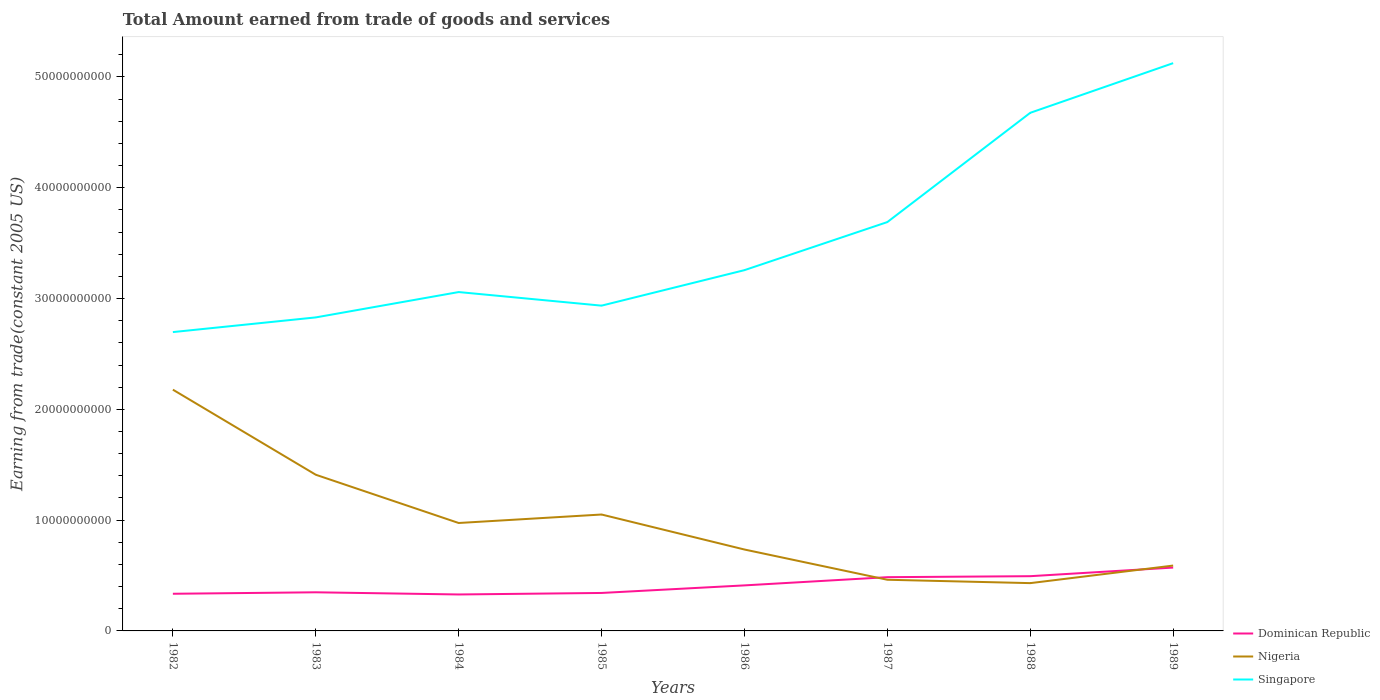Does the line corresponding to Nigeria intersect with the line corresponding to Singapore?
Your response must be concise. No. Is the number of lines equal to the number of legend labels?
Offer a terse response. Yes. Across all years, what is the maximum total amount earned by trading goods and services in Singapore?
Offer a terse response. 2.70e+1. What is the total total amount earned by trading goods and services in Dominican Republic in the graph?
Offer a terse response. -1.56e+09. What is the difference between the highest and the second highest total amount earned by trading goods and services in Nigeria?
Provide a short and direct response. 1.75e+1. What is the difference between the highest and the lowest total amount earned by trading goods and services in Dominican Republic?
Make the answer very short. 3. How many lines are there?
Keep it short and to the point. 3. How many years are there in the graph?
Offer a terse response. 8. What is the difference between two consecutive major ticks on the Y-axis?
Your answer should be compact. 1.00e+1. Are the values on the major ticks of Y-axis written in scientific E-notation?
Give a very brief answer. No. How are the legend labels stacked?
Make the answer very short. Vertical. What is the title of the graph?
Ensure brevity in your answer.  Total Amount earned from trade of goods and services. Does "Czech Republic" appear as one of the legend labels in the graph?
Ensure brevity in your answer.  No. What is the label or title of the X-axis?
Your response must be concise. Years. What is the label or title of the Y-axis?
Your answer should be compact. Earning from trade(constant 2005 US). What is the Earning from trade(constant 2005 US) of Dominican Republic in 1982?
Your answer should be compact. 3.35e+09. What is the Earning from trade(constant 2005 US) of Nigeria in 1982?
Your answer should be very brief. 2.18e+1. What is the Earning from trade(constant 2005 US) in Singapore in 1982?
Your response must be concise. 2.70e+1. What is the Earning from trade(constant 2005 US) in Dominican Republic in 1983?
Your answer should be compact. 3.49e+09. What is the Earning from trade(constant 2005 US) of Nigeria in 1983?
Keep it short and to the point. 1.41e+1. What is the Earning from trade(constant 2005 US) of Singapore in 1983?
Offer a terse response. 2.83e+1. What is the Earning from trade(constant 2005 US) in Dominican Republic in 1984?
Your response must be concise. 3.29e+09. What is the Earning from trade(constant 2005 US) in Nigeria in 1984?
Keep it short and to the point. 9.74e+09. What is the Earning from trade(constant 2005 US) of Singapore in 1984?
Make the answer very short. 3.06e+1. What is the Earning from trade(constant 2005 US) in Dominican Republic in 1985?
Your response must be concise. 3.43e+09. What is the Earning from trade(constant 2005 US) of Nigeria in 1985?
Give a very brief answer. 1.05e+1. What is the Earning from trade(constant 2005 US) in Singapore in 1985?
Offer a very short reply. 2.94e+1. What is the Earning from trade(constant 2005 US) of Dominican Republic in 1986?
Your answer should be very brief. 4.11e+09. What is the Earning from trade(constant 2005 US) in Nigeria in 1986?
Offer a very short reply. 7.35e+09. What is the Earning from trade(constant 2005 US) in Singapore in 1986?
Offer a terse response. 3.26e+1. What is the Earning from trade(constant 2005 US) of Dominican Republic in 1987?
Your answer should be very brief. 4.85e+09. What is the Earning from trade(constant 2005 US) of Nigeria in 1987?
Ensure brevity in your answer.  4.62e+09. What is the Earning from trade(constant 2005 US) in Singapore in 1987?
Ensure brevity in your answer.  3.69e+1. What is the Earning from trade(constant 2005 US) of Dominican Republic in 1988?
Your answer should be compact. 4.94e+09. What is the Earning from trade(constant 2005 US) of Nigeria in 1988?
Ensure brevity in your answer.  4.31e+09. What is the Earning from trade(constant 2005 US) in Singapore in 1988?
Offer a terse response. 4.68e+1. What is the Earning from trade(constant 2005 US) of Dominican Republic in 1989?
Ensure brevity in your answer.  5.72e+09. What is the Earning from trade(constant 2005 US) in Nigeria in 1989?
Offer a very short reply. 5.90e+09. What is the Earning from trade(constant 2005 US) of Singapore in 1989?
Keep it short and to the point. 5.12e+1. Across all years, what is the maximum Earning from trade(constant 2005 US) of Dominican Republic?
Your answer should be very brief. 5.72e+09. Across all years, what is the maximum Earning from trade(constant 2005 US) in Nigeria?
Offer a very short reply. 2.18e+1. Across all years, what is the maximum Earning from trade(constant 2005 US) of Singapore?
Your response must be concise. 5.12e+1. Across all years, what is the minimum Earning from trade(constant 2005 US) in Dominican Republic?
Offer a very short reply. 3.29e+09. Across all years, what is the minimum Earning from trade(constant 2005 US) in Nigeria?
Provide a short and direct response. 4.31e+09. Across all years, what is the minimum Earning from trade(constant 2005 US) of Singapore?
Provide a short and direct response. 2.70e+1. What is the total Earning from trade(constant 2005 US) of Dominican Republic in the graph?
Keep it short and to the point. 3.32e+1. What is the total Earning from trade(constant 2005 US) of Nigeria in the graph?
Keep it short and to the point. 7.83e+1. What is the total Earning from trade(constant 2005 US) in Singapore in the graph?
Offer a very short reply. 2.83e+11. What is the difference between the Earning from trade(constant 2005 US) in Dominican Republic in 1982 and that in 1983?
Offer a very short reply. -1.32e+08. What is the difference between the Earning from trade(constant 2005 US) in Nigeria in 1982 and that in 1983?
Provide a succinct answer. 7.68e+09. What is the difference between the Earning from trade(constant 2005 US) of Singapore in 1982 and that in 1983?
Ensure brevity in your answer.  -1.33e+09. What is the difference between the Earning from trade(constant 2005 US) in Dominican Republic in 1982 and that in 1984?
Give a very brief answer. 6.42e+07. What is the difference between the Earning from trade(constant 2005 US) in Nigeria in 1982 and that in 1984?
Provide a succinct answer. 1.20e+1. What is the difference between the Earning from trade(constant 2005 US) in Singapore in 1982 and that in 1984?
Offer a very short reply. -3.61e+09. What is the difference between the Earning from trade(constant 2005 US) in Dominican Republic in 1982 and that in 1985?
Provide a succinct answer. -7.25e+07. What is the difference between the Earning from trade(constant 2005 US) in Nigeria in 1982 and that in 1985?
Offer a terse response. 1.13e+1. What is the difference between the Earning from trade(constant 2005 US) in Singapore in 1982 and that in 1985?
Offer a terse response. -2.39e+09. What is the difference between the Earning from trade(constant 2005 US) of Dominican Republic in 1982 and that in 1986?
Offer a very short reply. -7.56e+08. What is the difference between the Earning from trade(constant 2005 US) in Nigeria in 1982 and that in 1986?
Provide a succinct answer. 1.44e+1. What is the difference between the Earning from trade(constant 2005 US) of Singapore in 1982 and that in 1986?
Your answer should be compact. -5.59e+09. What is the difference between the Earning from trade(constant 2005 US) in Dominican Republic in 1982 and that in 1987?
Provide a short and direct response. -1.50e+09. What is the difference between the Earning from trade(constant 2005 US) in Nigeria in 1982 and that in 1987?
Make the answer very short. 1.72e+1. What is the difference between the Earning from trade(constant 2005 US) in Singapore in 1982 and that in 1987?
Your answer should be compact. -9.93e+09. What is the difference between the Earning from trade(constant 2005 US) in Dominican Republic in 1982 and that in 1988?
Provide a short and direct response. -1.59e+09. What is the difference between the Earning from trade(constant 2005 US) in Nigeria in 1982 and that in 1988?
Give a very brief answer. 1.75e+1. What is the difference between the Earning from trade(constant 2005 US) of Singapore in 1982 and that in 1988?
Offer a very short reply. -1.98e+1. What is the difference between the Earning from trade(constant 2005 US) in Dominican Republic in 1982 and that in 1989?
Give a very brief answer. -2.36e+09. What is the difference between the Earning from trade(constant 2005 US) of Nigeria in 1982 and that in 1989?
Your answer should be compact. 1.59e+1. What is the difference between the Earning from trade(constant 2005 US) in Singapore in 1982 and that in 1989?
Offer a very short reply. -2.43e+1. What is the difference between the Earning from trade(constant 2005 US) in Dominican Republic in 1983 and that in 1984?
Make the answer very short. 1.96e+08. What is the difference between the Earning from trade(constant 2005 US) of Nigeria in 1983 and that in 1984?
Give a very brief answer. 4.36e+09. What is the difference between the Earning from trade(constant 2005 US) in Singapore in 1983 and that in 1984?
Your response must be concise. -2.29e+09. What is the difference between the Earning from trade(constant 2005 US) of Dominican Republic in 1983 and that in 1985?
Give a very brief answer. 5.93e+07. What is the difference between the Earning from trade(constant 2005 US) of Nigeria in 1983 and that in 1985?
Your response must be concise. 3.59e+09. What is the difference between the Earning from trade(constant 2005 US) of Singapore in 1983 and that in 1985?
Give a very brief answer. -1.06e+09. What is the difference between the Earning from trade(constant 2005 US) of Dominican Republic in 1983 and that in 1986?
Offer a terse response. -6.24e+08. What is the difference between the Earning from trade(constant 2005 US) in Nigeria in 1983 and that in 1986?
Provide a short and direct response. 6.75e+09. What is the difference between the Earning from trade(constant 2005 US) in Singapore in 1983 and that in 1986?
Ensure brevity in your answer.  -4.27e+09. What is the difference between the Earning from trade(constant 2005 US) of Dominican Republic in 1983 and that in 1987?
Your answer should be compact. -1.36e+09. What is the difference between the Earning from trade(constant 2005 US) of Nigeria in 1983 and that in 1987?
Ensure brevity in your answer.  9.48e+09. What is the difference between the Earning from trade(constant 2005 US) of Singapore in 1983 and that in 1987?
Offer a very short reply. -8.60e+09. What is the difference between the Earning from trade(constant 2005 US) of Dominican Republic in 1983 and that in 1988?
Your response must be concise. -1.45e+09. What is the difference between the Earning from trade(constant 2005 US) of Nigeria in 1983 and that in 1988?
Your response must be concise. 9.78e+09. What is the difference between the Earning from trade(constant 2005 US) of Singapore in 1983 and that in 1988?
Ensure brevity in your answer.  -1.85e+1. What is the difference between the Earning from trade(constant 2005 US) of Dominican Republic in 1983 and that in 1989?
Your answer should be very brief. -2.23e+09. What is the difference between the Earning from trade(constant 2005 US) in Nigeria in 1983 and that in 1989?
Your response must be concise. 8.20e+09. What is the difference between the Earning from trade(constant 2005 US) in Singapore in 1983 and that in 1989?
Make the answer very short. -2.29e+1. What is the difference between the Earning from trade(constant 2005 US) of Dominican Republic in 1984 and that in 1985?
Your answer should be compact. -1.37e+08. What is the difference between the Earning from trade(constant 2005 US) in Nigeria in 1984 and that in 1985?
Your answer should be compact. -7.65e+08. What is the difference between the Earning from trade(constant 2005 US) in Singapore in 1984 and that in 1985?
Make the answer very short. 1.23e+09. What is the difference between the Earning from trade(constant 2005 US) of Dominican Republic in 1984 and that in 1986?
Keep it short and to the point. -8.20e+08. What is the difference between the Earning from trade(constant 2005 US) in Nigeria in 1984 and that in 1986?
Provide a succinct answer. 2.39e+09. What is the difference between the Earning from trade(constant 2005 US) in Singapore in 1984 and that in 1986?
Give a very brief answer. -1.98e+09. What is the difference between the Earning from trade(constant 2005 US) of Dominican Republic in 1984 and that in 1987?
Ensure brevity in your answer.  -1.56e+09. What is the difference between the Earning from trade(constant 2005 US) in Nigeria in 1984 and that in 1987?
Make the answer very short. 5.12e+09. What is the difference between the Earning from trade(constant 2005 US) of Singapore in 1984 and that in 1987?
Ensure brevity in your answer.  -6.32e+09. What is the difference between the Earning from trade(constant 2005 US) in Dominican Republic in 1984 and that in 1988?
Your answer should be very brief. -1.65e+09. What is the difference between the Earning from trade(constant 2005 US) of Nigeria in 1984 and that in 1988?
Your answer should be compact. 5.43e+09. What is the difference between the Earning from trade(constant 2005 US) of Singapore in 1984 and that in 1988?
Your response must be concise. -1.62e+1. What is the difference between the Earning from trade(constant 2005 US) in Dominican Republic in 1984 and that in 1989?
Offer a terse response. -2.43e+09. What is the difference between the Earning from trade(constant 2005 US) of Nigeria in 1984 and that in 1989?
Your answer should be compact. 3.84e+09. What is the difference between the Earning from trade(constant 2005 US) of Singapore in 1984 and that in 1989?
Your response must be concise. -2.07e+1. What is the difference between the Earning from trade(constant 2005 US) of Dominican Republic in 1985 and that in 1986?
Your answer should be compact. -6.84e+08. What is the difference between the Earning from trade(constant 2005 US) in Nigeria in 1985 and that in 1986?
Your response must be concise. 3.16e+09. What is the difference between the Earning from trade(constant 2005 US) of Singapore in 1985 and that in 1986?
Your response must be concise. -3.20e+09. What is the difference between the Earning from trade(constant 2005 US) of Dominican Republic in 1985 and that in 1987?
Your answer should be very brief. -1.42e+09. What is the difference between the Earning from trade(constant 2005 US) in Nigeria in 1985 and that in 1987?
Your response must be concise. 5.89e+09. What is the difference between the Earning from trade(constant 2005 US) of Singapore in 1985 and that in 1987?
Your response must be concise. -7.54e+09. What is the difference between the Earning from trade(constant 2005 US) in Dominican Republic in 1985 and that in 1988?
Offer a very short reply. -1.51e+09. What is the difference between the Earning from trade(constant 2005 US) in Nigeria in 1985 and that in 1988?
Your response must be concise. 6.19e+09. What is the difference between the Earning from trade(constant 2005 US) of Singapore in 1985 and that in 1988?
Offer a terse response. -1.74e+1. What is the difference between the Earning from trade(constant 2005 US) in Dominican Republic in 1985 and that in 1989?
Your answer should be compact. -2.29e+09. What is the difference between the Earning from trade(constant 2005 US) in Nigeria in 1985 and that in 1989?
Make the answer very short. 4.61e+09. What is the difference between the Earning from trade(constant 2005 US) in Singapore in 1985 and that in 1989?
Make the answer very short. -2.19e+1. What is the difference between the Earning from trade(constant 2005 US) of Dominican Republic in 1986 and that in 1987?
Give a very brief answer. -7.41e+08. What is the difference between the Earning from trade(constant 2005 US) in Nigeria in 1986 and that in 1987?
Your answer should be compact. 2.73e+09. What is the difference between the Earning from trade(constant 2005 US) of Singapore in 1986 and that in 1987?
Your answer should be very brief. -4.34e+09. What is the difference between the Earning from trade(constant 2005 US) in Dominican Republic in 1986 and that in 1988?
Ensure brevity in your answer.  -8.30e+08. What is the difference between the Earning from trade(constant 2005 US) of Nigeria in 1986 and that in 1988?
Ensure brevity in your answer.  3.03e+09. What is the difference between the Earning from trade(constant 2005 US) in Singapore in 1986 and that in 1988?
Keep it short and to the point. -1.42e+1. What is the difference between the Earning from trade(constant 2005 US) in Dominican Republic in 1986 and that in 1989?
Offer a terse response. -1.61e+09. What is the difference between the Earning from trade(constant 2005 US) of Nigeria in 1986 and that in 1989?
Keep it short and to the point. 1.45e+09. What is the difference between the Earning from trade(constant 2005 US) in Singapore in 1986 and that in 1989?
Offer a very short reply. -1.87e+1. What is the difference between the Earning from trade(constant 2005 US) of Dominican Republic in 1987 and that in 1988?
Your answer should be very brief. -8.89e+07. What is the difference between the Earning from trade(constant 2005 US) in Nigeria in 1987 and that in 1988?
Provide a succinct answer. 3.05e+08. What is the difference between the Earning from trade(constant 2005 US) of Singapore in 1987 and that in 1988?
Your answer should be compact. -9.86e+09. What is the difference between the Earning from trade(constant 2005 US) of Dominican Republic in 1987 and that in 1989?
Provide a short and direct response. -8.68e+08. What is the difference between the Earning from trade(constant 2005 US) of Nigeria in 1987 and that in 1989?
Offer a terse response. -1.28e+09. What is the difference between the Earning from trade(constant 2005 US) in Singapore in 1987 and that in 1989?
Make the answer very short. -1.43e+1. What is the difference between the Earning from trade(constant 2005 US) of Dominican Republic in 1988 and that in 1989?
Keep it short and to the point. -7.79e+08. What is the difference between the Earning from trade(constant 2005 US) in Nigeria in 1988 and that in 1989?
Ensure brevity in your answer.  -1.59e+09. What is the difference between the Earning from trade(constant 2005 US) of Singapore in 1988 and that in 1989?
Give a very brief answer. -4.48e+09. What is the difference between the Earning from trade(constant 2005 US) in Dominican Republic in 1982 and the Earning from trade(constant 2005 US) in Nigeria in 1983?
Ensure brevity in your answer.  -1.07e+1. What is the difference between the Earning from trade(constant 2005 US) in Dominican Republic in 1982 and the Earning from trade(constant 2005 US) in Singapore in 1983?
Your answer should be very brief. -2.49e+1. What is the difference between the Earning from trade(constant 2005 US) in Nigeria in 1982 and the Earning from trade(constant 2005 US) in Singapore in 1983?
Provide a short and direct response. -6.52e+09. What is the difference between the Earning from trade(constant 2005 US) of Dominican Republic in 1982 and the Earning from trade(constant 2005 US) of Nigeria in 1984?
Keep it short and to the point. -6.39e+09. What is the difference between the Earning from trade(constant 2005 US) of Dominican Republic in 1982 and the Earning from trade(constant 2005 US) of Singapore in 1984?
Provide a short and direct response. -2.72e+1. What is the difference between the Earning from trade(constant 2005 US) of Nigeria in 1982 and the Earning from trade(constant 2005 US) of Singapore in 1984?
Ensure brevity in your answer.  -8.81e+09. What is the difference between the Earning from trade(constant 2005 US) in Dominican Republic in 1982 and the Earning from trade(constant 2005 US) in Nigeria in 1985?
Offer a very short reply. -7.15e+09. What is the difference between the Earning from trade(constant 2005 US) in Dominican Republic in 1982 and the Earning from trade(constant 2005 US) in Singapore in 1985?
Give a very brief answer. -2.60e+1. What is the difference between the Earning from trade(constant 2005 US) in Nigeria in 1982 and the Earning from trade(constant 2005 US) in Singapore in 1985?
Your answer should be compact. -7.58e+09. What is the difference between the Earning from trade(constant 2005 US) of Dominican Republic in 1982 and the Earning from trade(constant 2005 US) of Nigeria in 1986?
Offer a very short reply. -3.99e+09. What is the difference between the Earning from trade(constant 2005 US) in Dominican Republic in 1982 and the Earning from trade(constant 2005 US) in Singapore in 1986?
Offer a very short reply. -2.92e+1. What is the difference between the Earning from trade(constant 2005 US) in Nigeria in 1982 and the Earning from trade(constant 2005 US) in Singapore in 1986?
Offer a very short reply. -1.08e+1. What is the difference between the Earning from trade(constant 2005 US) of Dominican Republic in 1982 and the Earning from trade(constant 2005 US) of Nigeria in 1987?
Offer a very short reply. -1.26e+09. What is the difference between the Earning from trade(constant 2005 US) in Dominican Republic in 1982 and the Earning from trade(constant 2005 US) in Singapore in 1987?
Your answer should be very brief. -3.35e+1. What is the difference between the Earning from trade(constant 2005 US) in Nigeria in 1982 and the Earning from trade(constant 2005 US) in Singapore in 1987?
Provide a succinct answer. -1.51e+1. What is the difference between the Earning from trade(constant 2005 US) in Dominican Republic in 1982 and the Earning from trade(constant 2005 US) in Nigeria in 1988?
Offer a very short reply. -9.59e+08. What is the difference between the Earning from trade(constant 2005 US) of Dominican Republic in 1982 and the Earning from trade(constant 2005 US) of Singapore in 1988?
Make the answer very short. -4.34e+1. What is the difference between the Earning from trade(constant 2005 US) in Nigeria in 1982 and the Earning from trade(constant 2005 US) in Singapore in 1988?
Ensure brevity in your answer.  -2.50e+1. What is the difference between the Earning from trade(constant 2005 US) of Dominican Republic in 1982 and the Earning from trade(constant 2005 US) of Nigeria in 1989?
Keep it short and to the point. -2.54e+09. What is the difference between the Earning from trade(constant 2005 US) of Dominican Republic in 1982 and the Earning from trade(constant 2005 US) of Singapore in 1989?
Your answer should be very brief. -4.79e+1. What is the difference between the Earning from trade(constant 2005 US) in Nigeria in 1982 and the Earning from trade(constant 2005 US) in Singapore in 1989?
Give a very brief answer. -2.95e+1. What is the difference between the Earning from trade(constant 2005 US) of Dominican Republic in 1983 and the Earning from trade(constant 2005 US) of Nigeria in 1984?
Offer a very short reply. -6.26e+09. What is the difference between the Earning from trade(constant 2005 US) in Dominican Republic in 1983 and the Earning from trade(constant 2005 US) in Singapore in 1984?
Provide a succinct answer. -2.71e+1. What is the difference between the Earning from trade(constant 2005 US) of Nigeria in 1983 and the Earning from trade(constant 2005 US) of Singapore in 1984?
Your answer should be very brief. -1.65e+1. What is the difference between the Earning from trade(constant 2005 US) in Dominican Republic in 1983 and the Earning from trade(constant 2005 US) in Nigeria in 1985?
Offer a terse response. -7.02e+09. What is the difference between the Earning from trade(constant 2005 US) in Dominican Republic in 1983 and the Earning from trade(constant 2005 US) in Singapore in 1985?
Your answer should be compact. -2.59e+1. What is the difference between the Earning from trade(constant 2005 US) of Nigeria in 1983 and the Earning from trade(constant 2005 US) of Singapore in 1985?
Offer a very short reply. -1.53e+1. What is the difference between the Earning from trade(constant 2005 US) in Dominican Republic in 1983 and the Earning from trade(constant 2005 US) in Nigeria in 1986?
Make the answer very short. -3.86e+09. What is the difference between the Earning from trade(constant 2005 US) in Dominican Republic in 1983 and the Earning from trade(constant 2005 US) in Singapore in 1986?
Offer a very short reply. -2.91e+1. What is the difference between the Earning from trade(constant 2005 US) in Nigeria in 1983 and the Earning from trade(constant 2005 US) in Singapore in 1986?
Provide a succinct answer. -1.85e+1. What is the difference between the Earning from trade(constant 2005 US) of Dominican Republic in 1983 and the Earning from trade(constant 2005 US) of Nigeria in 1987?
Make the answer very short. -1.13e+09. What is the difference between the Earning from trade(constant 2005 US) in Dominican Republic in 1983 and the Earning from trade(constant 2005 US) in Singapore in 1987?
Your answer should be very brief. -3.34e+1. What is the difference between the Earning from trade(constant 2005 US) in Nigeria in 1983 and the Earning from trade(constant 2005 US) in Singapore in 1987?
Provide a succinct answer. -2.28e+1. What is the difference between the Earning from trade(constant 2005 US) in Dominican Republic in 1983 and the Earning from trade(constant 2005 US) in Nigeria in 1988?
Offer a terse response. -8.28e+08. What is the difference between the Earning from trade(constant 2005 US) of Dominican Republic in 1983 and the Earning from trade(constant 2005 US) of Singapore in 1988?
Your answer should be compact. -4.33e+1. What is the difference between the Earning from trade(constant 2005 US) of Nigeria in 1983 and the Earning from trade(constant 2005 US) of Singapore in 1988?
Your answer should be very brief. -3.27e+1. What is the difference between the Earning from trade(constant 2005 US) of Dominican Republic in 1983 and the Earning from trade(constant 2005 US) of Nigeria in 1989?
Give a very brief answer. -2.41e+09. What is the difference between the Earning from trade(constant 2005 US) in Dominican Republic in 1983 and the Earning from trade(constant 2005 US) in Singapore in 1989?
Your answer should be very brief. -4.78e+1. What is the difference between the Earning from trade(constant 2005 US) of Nigeria in 1983 and the Earning from trade(constant 2005 US) of Singapore in 1989?
Your answer should be very brief. -3.71e+1. What is the difference between the Earning from trade(constant 2005 US) of Dominican Republic in 1984 and the Earning from trade(constant 2005 US) of Nigeria in 1985?
Give a very brief answer. -7.22e+09. What is the difference between the Earning from trade(constant 2005 US) in Dominican Republic in 1984 and the Earning from trade(constant 2005 US) in Singapore in 1985?
Keep it short and to the point. -2.61e+1. What is the difference between the Earning from trade(constant 2005 US) in Nigeria in 1984 and the Earning from trade(constant 2005 US) in Singapore in 1985?
Provide a short and direct response. -1.96e+1. What is the difference between the Earning from trade(constant 2005 US) of Dominican Republic in 1984 and the Earning from trade(constant 2005 US) of Nigeria in 1986?
Offer a terse response. -4.06e+09. What is the difference between the Earning from trade(constant 2005 US) in Dominican Republic in 1984 and the Earning from trade(constant 2005 US) in Singapore in 1986?
Give a very brief answer. -2.93e+1. What is the difference between the Earning from trade(constant 2005 US) in Nigeria in 1984 and the Earning from trade(constant 2005 US) in Singapore in 1986?
Your response must be concise. -2.28e+1. What is the difference between the Earning from trade(constant 2005 US) in Dominican Republic in 1984 and the Earning from trade(constant 2005 US) in Nigeria in 1987?
Make the answer very short. -1.33e+09. What is the difference between the Earning from trade(constant 2005 US) of Dominican Republic in 1984 and the Earning from trade(constant 2005 US) of Singapore in 1987?
Your answer should be very brief. -3.36e+1. What is the difference between the Earning from trade(constant 2005 US) of Nigeria in 1984 and the Earning from trade(constant 2005 US) of Singapore in 1987?
Keep it short and to the point. -2.72e+1. What is the difference between the Earning from trade(constant 2005 US) in Dominican Republic in 1984 and the Earning from trade(constant 2005 US) in Nigeria in 1988?
Your response must be concise. -1.02e+09. What is the difference between the Earning from trade(constant 2005 US) of Dominican Republic in 1984 and the Earning from trade(constant 2005 US) of Singapore in 1988?
Give a very brief answer. -4.35e+1. What is the difference between the Earning from trade(constant 2005 US) in Nigeria in 1984 and the Earning from trade(constant 2005 US) in Singapore in 1988?
Your answer should be very brief. -3.70e+1. What is the difference between the Earning from trade(constant 2005 US) in Dominican Republic in 1984 and the Earning from trade(constant 2005 US) in Nigeria in 1989?
Make the answer very short. -2.61e+09. What is the difference between the Earning from trade(constant 2005 US) of Dominican Republic in 1984 and the Earning from trade(constant 2005 US) of Singapore in 1989?
Provide a succinct answer. -4.80e+1. What is the difference between the Earning from trade(constant 2005 US) in Nigeria in 1984 and the Earning from trade(constant 2005 US) in Singapore in 1989?
Provide a short and direct response. -4.15e+1. What is the difference between the Earning from trade(constant 2005 US) of Dominican Republic in 1985 and the Earning from trade(constant 2005 US) of Nigeria in 1986?
Offer a terse response. -3.92e+09. What is the difference between the Earning from trade(constant 2005 US) in Dominican Republic in 1985 and the Earning from trade(constant 2005 US) in Singapore in 1986?
Provide a short and direct response. -2.91e+1. What is the difference between the Earning from trade(constant 2005 US) of Nigeria in 1985 and the Earning from trade(constant 2005 US) of Singapore in 1986?
Keep it short and to the point. -2.21e+1. What is the difference between the Earning from trade(constant 2005 US) of Dominican Republic in 1985 and the Earning from trade(constant 2005 US) of Nigeria in 1987?
Make the answer very short. -1.19e+09. What is the difference between the Earning from trade(constant 2005 US) of Dominican Republic in 1985 and the Earning from trade(constant 2005 US) of Singapore in 1987?
Your answer should be very brief. -3.35e+1. What is the difference between the Earning from trade(constant 2005 US) of Nigeria in 1985 and the Earning from trade(constant 2005 US) of Singapore in 1987?
Give a very brief answer. -2.64e+1. What is the difference between the Earning from trade(constant 2005 US) in Dominican Republic in 1985 and the Earning from trade(constant 2005 US) in Nigeria in 1988?
Offer a terse response. -8.87e+08. What is the difference between the Earning from trade(constant 2005 US) in Dominican Republic in 1985 and the Earning from trade(constant 2005 US) in Singapore in 1988?
Provide a short and direct response. -4.33e+1. What is the difference between the Earning from trade(constant 2005 US) of Nigeria in 1985 and the Earning from trade(constant 2005 US) of Singapore in 1988?
Provide a succinct answer. -3.63e+1. What is the difference between the Earning from trade(constant 2005 US) in Dominican Republic in 1985 and the Earning from trade(constant 2005 US) in Nigeria in 1989?
Give a very brief answer. -2.47e+09. What is the difference between the Earning from trade(constant 2005 US) of Dominican Republic in 1985 and the Earning from trade(constant 2005 US) of Singapore in 1989?
Offer a very short reply. -4.78e+1. What is the difference between the Earning from trade(constant 2005 US) of Nigeria in 1985 and the Earning from trade(constant 2005 US) of Singapore in 1989?
Your response must be concise. -4.07e+1. What is the difference between the Earning from trade(constant 2005 US) of Dominican Republic in 1986 and the Earning from trade(constant 2005 US) of Nigeria in 1987?
Make the answer very short. -5.08e+08. What is the difference between the Earning from trade(constant 2005 US) in Dominican Republic in 1986 and the Earning from trade(constant 2005 US) in Singapore in 1987?
Your answer should be very brief. -3.28e+1. What is the difference between the Earning from trade(constant 2005 US) of Nigeria in 1986 and the Earning from trade(constant 2005 US) of Singapore in 1987?
Your answer should be very brief. -2.96e+1. What is the difference between the Earning from trade(constant 2005 US) of Dominican Republic in 1986 and the Earning from trade(constant 2005 US) of Nigeria in 1988?
Give a very brief answer. -2.03e+08. What is the difference between the Earning from trade(constant 2005 US) in Dominican Republic in 1986 and the Earning from trade(constant 2005 US) in Singapore in 1988?
Provide a short and direct response. -4.27e+1. What is the difference between the Earning from trade(constant 2005 US) in Nigeria in 1986 and the Earning from trade(constant 2005 US) in Singapore in 1988?
Your answer should be compact. -3.94e+1. What is the difference between the Earning from trade(constant 2005 US) in Dominican Republic in 1986 and the Earning from trade(constant 2005 US) in Nigeria in 1989?
Your answer should be compact. -1.79e+09. What is the difference between the Earning from trade(constant 2005 US) of Dominican Republic in 1986 and the Earning from trade(constant 2005 US) of Singapore in 1989?
Make the answer very short. -4.71e+1. What is the difference between the Earning from trade(constant 2005 US) of Nigeria in 1986 and the Earning from trade(constant 2005 US) of Singapore in 1989?
Provide a short and direct response. -4.39e+1. What is the difference between the Earning from trade(constant 2005 US) in Dominican Republic in 1987 and the Earning from trade(constant 2005 US) in Nigeria in 1988?
Ensure brevity in your answer.  5.37e+08. What is the difference between the Earning from trade(constant 2005 US) in Dominican Republic in 1987 and the Earning from trade(constant 2005 US) in Singapore in 1988?
Offer a very short reply. -4.19e+1. What is the difference between the Earning from trade(constant 2005 US) in Nigeria in 1987 and the Earning from trade(constant 2005 US) in Singapore in 1988?
Your answer should be compact. -4.21e+1. What is the difference between the Earning from trade(constant 2005 US) of Dominican Republic in 1987 and the Earning from trade(constant 2005 US) of Nigeria in 1989?
Provide a short and direct response. -1.05e+09. What is the difference between the Earning from trade(constant 2005 US) in Dominican Republic in 1987 and the Earning from trade(constant 2005 US) in Singapore in 1989?
Your response must be concise. -4.64e+1. What is the difference between the Earning from trade(constant 2005 US) in Nigeria in 1987 and the Earning from trade(constant 2005 US) in Singapore in 1989?
Give a very brief answer. -4.66e+1. What is the difference between the Earning from trade(constant 2005 US) of Dominican Republic in 1988 and the Earning from trade(constant 2005 US) of Nigeria in 1989?
Provide a short and direct response. -9.59e+08. What is the difference between the Earning from trade(constant 2005 US) of Dominican Republic in 1988 and the Earning from trade(constant 2005 US) of Singapore in 1989?
Offer a very short reply. -4.63e+1. What is the difference between the Earning from trade(constant 2005 US) in Nigeria in 1988 and the Earning from trade(constant 2005 US) in Singapore in 1989?
Ensure brevity in your answer.  -4.69e+1. What is the average Earning from trade(constant 2005 US) in Dominican Republic per year?
Provide a succinct answer. 4.15e+09. What is the average Earning from trade(constant 2005 US) of Nigeria per year?
Your answer should be compact. 9.79e+09. What is the average Earning from trade(constant 2005 US) of Singapore per year?
Ensure brevity in your answer.  3.53e+1. In the year 1982, what is the difference between the Earning from trade(constant 2005 US) in Dominican Republic and Earning from trade(constant 2005 US) in Nigeria?
Your response must be concise. -1.84e+1. In the year 1982, what is the difference between the Earning from trade(constant 2005 US) in Dominican Republic and Earning from trade(constant 2005 US) in Singapore?
Your response must be concise. -2.36e+1. In the year 1982, what is the difference between the Earning from trade(constant 2005 US) in Nigeria and Earning from trade(constant 2005 US) in Singapore?
Offer a terse response. -5.20e+09. In the year 1983, what is the difference between the Earning from trade(constant 2005 US) of Dominican Republic and Earning from trade(constant 2005 US) of Nigeria?
Provide a succinct answer. -1.06e+1. In the year 1983, what is the difference between the Earning from trade(constant 2005 US) in Dominican Republic and Earning from trade(constant 2005 US) in Singapore?
Ensure brevity in your answer.  -2.48e+1. In the year 1983, what is the difference between the Earning from trade(constant 2005 US) of Nigeria and Earning from trade(constant 2005 US) of Singapore?
Ensure brevity in your answer.  -1.42e+1. In the year 1984, what is the difference between the Earning from trade(constant 2005 US) in Dominican Republic and Earning from trade(constant 2005 US) in Nigeria?
Your answer should be very brief. -6.45e+09. In the year 1984, what is the difference between the Earning from trade(constant 2005 US) in Dominican Republic and Earning from trade(constant 2005 US) in Singapore?
Offer a terse response. -2.73e+1. In the year 1984, what is the difference between the Earning from trade(constant 2005 US) of Nigeria and Earning from trade(constant 2005 US) of Singapore?
Make the answer very short. -2.08e+1. In the year 1985, what is the difference between the Earning from trade(constant 2005 US) in Dominican Republic and Earning from trade(constant 2005 US) in Nigeria?
Provide a succinct answer. -7.08e+09. In the year 1985, what is the difference between the Earning from trade(constant 2005 US) in Dominican Republic and Earning from trade(constant 2005 US) in Singapore?
Keep it short and to the point. -2.59e+1. In the year 1985, what is the difference between the Earning from trade(constant 2005 US) in Nigeria and Earning from trade(constant 2005 US) in Singapore?
Ensure brevity in your answer.  -1.89e+1. In the year 1986, what is the difference between the Earning from trade(constant 2005 US) in Dominican Republic and Earning from trade(constant 2005 US) in Nigeria?
Make the answer very short. -3.24e+09. In the year 1986, what is the difference between the Earning from trade(constant 2005 US) of Dominican Republic and Earning from trade(constant 2005 US) of Singapore?
Offer a terse response. -2.85e+1. In the year 1986, what is the difference between the Earning from trade(constant 2005 US) of Nigeria and Earning from trade(constant 2005 US) of Singapore?
Give a very brief answer. -2.52e+1. In the year 1987, what is the difference between the Earning from trade(constant 2005 US) in Dominican Republic and Earning from trade(constant 2005 US) in Nigeria?
Your response must be concise. 2.32e+08. In the year 1987, what is the difference between the Earning from trade(constant 2005 US) in Dominican Republic and Earning from trade(constant 2005 US) in Singapore?
Your answer should be compact. -3.21e+1. In the year 1987, what is the difference between the Earning from trade(constant 2005 US) of Nigeria and Earning from trade(constant 2005 US) of Singapore?
Your answer should be compact. -3.23e+1. In the year 1988, what is the difference between the Earning from trade(constant 2005 US) in Dominican Republic and Earning from trade(constant 2005 US) in Nigeria?
Your answer should be compact. 6.26e+08. In the year 1988, what is the difference between the Earning from trade(constant 2005 US) of Dominican Republic and Earning from trade(constant 2005 US) of Singapore?
Your answer should be very brief. -4.18e+1. In the year 1988, what is the difference between the Earning from trade(constant 2005 US) of Nigeria and Earning from trade(constant 2005 US) of Singapore?
Provide a short and direct response. -4.24e+1. In the year 1989, what is the difference between the Earning from trade(constant 2005 US) in Dominican Republic and Earning from trade(constant 2005 US) in Nigeria?
Your response must be concise. -1.80e+08. In the year 1989, what is the difference between the Earning from trade(constant 2005 US) of Dominican Republic and Earning from trade(constant 2005 US) of Singapore?
Your answer should be very brief. -4.55e+1. In the year 1989, what is the difference between the Earning from trade(constant 2005 US) of Nigeria and Earning from trade(constant 2005 US) of Singapore?
Make the answer very short. -4.53e+1. What is the ratio of the Earning from trade(constant 2005 US) in Dominican Republic in 1982 to that in 1983?
Give a very brief answer. 0.96. What is the ratio of the Earning from trade(constant 2005 US) in Nigeria in 1982 to that in 1983?
Keep it short and to the point. 1.54. What is the ratio of the Earning from trade(constant 2005 US) of Singapore in 1982 to that in 1983?
Ensure brevity in your answer.  0.95. What is the ratio of the Earning from trade(constant 2005 US) of Dominican Republic in 1982 to that in 1984?
Give a very brief answer. 1.02. What is the ratio of the Earning from trade(constant 2005 US) in Nigeria in 1982 to that in 1984?
Provide a succinct answer. 2.24. What is the ratio of the Earning from trade(constant 2005 US) of Singapore in 1982 to that in 1984?
Provide a short and direct response. 0.88. What is the ratio of the Earning from trade(constant 2005 US) of Dominican Republic in 1982 to that in 1985?
Your response must be concise. 0.98. What is the ratio of the Earning from trade(constant 2005 US) in Nigeria in 1982 to that in 1985?
Your answer should be compact. 2.07. What is the ratio of the Earning from trade(constant 2005 US) in Singapore in 1982 to that in 1985?
Keep it short and to the point. 0.92. What is the ratio of the Earning from trade(constant 2005 US) in Dominican Republic in 1982 to that in 1986?
Your answer should be very brief. 0.82. What is the ratio of the Earning from trade(constant 2005 US) in Nigeria in 1982 to that in 1986?
Make the answer very short. 2.96. What is the ratio of the Earning from trade(constant 2005 US) in Singapore in 1982 to that in 1986?
Your response must be concise. 0.83. What is the ratio of the Earning from trade(constant 2005 US) in Dominican Republic in 1982 to that in 1987?
Your answer should be very brief. 0.69. What is the ratio of the Earning from trade(constant 2005 US) of Nigeria in 1982 to that in 1987?
Offer a terse response. 4.72. What is the ratio of the Earning from trade(constant 2005 US) of Singapore in 1982 to that in 1987?
Offer a terse response. 0.73. What is the ratio of the Earning from trade(constant 2005 US) in Dominican Republic in 1982 to that in 1988?
Provide a succinct answer. 0.68. What is the ratio of the Earning from trade(constant 2005 US) in Nigeria in 1982 to that in 1988?
Provide a short and direct response. 5.05. What is the ratio of the Earning from trade(constant 2005 US) of Singapore in 1982 to that in 1988?
Make the answer very short. 0.58. What is the ratio of the Earning from trade(constant 2005 US) of Dominican Republic in 1982 to that in 1989?
Offer a very short reply. 0.59. What is the ratio of the Earning from trade(constant 2005 US) of Nigeria in 1982 to that in 1989?
Offer a terse response. 3.69. What is the ratio of the Earning from trade(constant 2005 US) of Singapore in 1982 to that in 1989?
Offer a very short reply. 0.53. What is the ratio of the Earning from trade(constant 2005 US) of Dominican Republic in 1983 to that in 1984?
Your answer should be compact. 1.06. What is the ratio of the Earning from trade(constant 2005 US) of Nigeria in 1983 to that in 1984?
Your answer should be compact. 1.45. What is the ratio of the Earning from trade(constant 2005 US) in Singapore in 1983 to that in 1984?
Provide a succinct answer. 0.93. What is the ratio of the Earning from trade(constant 2005 US) in Dominican Republic in 1983 to that in 1985?
Ensure brevity in your answer.  1.02. What is the ratio of the Earning from trade(constant 2005 US) of Nigeria in 1983 to that in 1985?
Keep it short and to the point. 1.34. What is the ratio of the Earning from trade(constant 2005 US) in Singapore in 1983 to that in 1985?
Offer a terse response. 0.96. What is the ratio of the Earning from trade(constant 2005 US) in Dominican Republic in 1983 to that in 1986?
Make the answer very short. 0.85. What is the ratio of the Earning from trade(constant 2005 US) of Nigeria in 1983 to that in 1986?
Offer a very short reply. 1.92. What is the ratio of the Earning from trade(constant 2005 US) of Singapore in 1983 to that in 1986?
Your response must be concise. 0.87. What is the ratio of the Earning from trade(constant 2005 US) of Dominican Republic in 1983 to that in 1987?
Offer a very short reply. 0.72. What is the ratio of the Earning from trade(constant 2005 US) of Nigeria in 1983 to that in 1987?
Your answer should be compact. 3.05. What is the ratio of the Earning from trade(constant 2005 US) in Singapore in 1983 to that in 1987?
Offer a terse response. 0.77. What is the ratio of the Earning from trade(constant 2005 US) of Dominican Republic in 1983 to that in 1988?
Your answer should be compact. 0.71. What is the ratio of the Earning from trade(constant 2005 US) in Nigeria in 1983 to that in 1988?
Your answer should be compact. 3.27. What is the ratio of the Earning from trade(constant 2005 US) of Singapore in 1983 to that in 1988?
Offer a very short reply. 0.61. What is the ratio of the Earning from trade(constant 2005 US) of Dominican Republic in 1983 to that in 1989?
Give a very brief answer. 0.61. What is the ratio of the Earning from trade(constant 2005 US) in Nigeria in 1983 to that in 1989?
Keep it short and to the point. 2.39. What is the ratio of the Earning from trade(constant 2005 US) in Singapore in 1983 to that in 1989?
Give a very brief answer. 0.55. What is the ratio of the Earning from trade(constant 2005 US) in Dominican Republic in 1984 to that in 1985?
Offer a very short reply. 0.96. What is the ratio of the Earning from trade(constant 2005 US) in Nigeria in 1984 to that in 1985?
Ensure brevity in your answer.  0.93. What is the ratio of the Earning from trade(constant 2005 US) in Singapore in 1984 to that in 1985?
Keep it short and to the point. 1.04. What is the ratio of the Earning from trade(constant 2005 US) of Dominican Republic in 1984 to that in 1986?
Make the answer very short. 0.8. What is the ratio of the Earning from trade(constant 2005 US) of Nigeria in 1984 to that in 1986?
Your response must be concise. 1.33. What is the ratio of the Earning from trade(constant 2005 US) of Singapore in 1984 to that in 1986?
Your answer should be very brief. 0.94. What is the ratio of the Earning from trade(constant 2005 US) of Dominican Republic in 1984 to that in 1987?
Your answer should be compact. 0.68. What is the ratio of the Earning from trade(constant 2005 US) of Nigeria in 1984 to that in 1987?
Make the answer very short. 2.11. What is the ratio of the Earning from trade(constant 2005 US) of Singapore in 1984 to that in 1987?
Your answer should be compact. 0.83. What is the ratio of the Earning from trade(constant 2005 US) in Dominican Republic in 1984 to that in 1988?
Provide a short and direct response. 0.67. What is the ratio of the Earning from trade(constant 2005 US) of Nigeria in 1984 to that in 1988?
Offer a terse response. 2.26. What is the ratio of the Earning from trade(constant 2005 US) of Singapore in 1984 to that in 1988?
Your answer should be compact. 0.65. What is the ratio of the Earning from trade(constant 2005 US) in Dominican Republic in 1984 to that in 1989?
Keep it short and to the point. 0.58. What is the ratio of the Earning from trade(constant 2005 US) in Nigeria in 1984 to that in 1989?
Keep it short and to the point. 1.65. What is the ratio of the Earning from trade(constant 2005 US) of Singapore in 1984 to that in 1989?
Keep it short and to the point. 0.6. What is the ratio of the Earning from trade(constant 2005 US) in Dominican Republic in 1985 to that in 1986?
Provide a succinct answer. 0.83. What is the ratio of the Earning from trade(constant 2005 US) of Nigeria in 1985 to that in 1986?
Provide a succinct answer. 1.43. What is the ratio of the Earning from trade(constant 2005 US) of Singapore in 1985 to that in 1986?
Provide a short and direct response. 0.9. What is the ratio of the Earning from trade(constant 2005 US) of Dominican Republic in 1985 to that in 1987?
Make the answer very short. 0.71. What is the ratio of the Earning from trade(constant 2005 US) in Nigeria in 1985 to that in 1987?
Make the answer very short. 2.27. What is the ratio of the Earning from trade(constant 2005 US) of Singapore in 1985 to that in 1987?
Your answer should be very brief. 0.8. What is the ratio of the Earning from trade(constant 2005 US) in Dominican Republic in 1985 to that in 1988?
Give a very brief answer. 0.69. What is the ratio of the Earning from trade(constant 2005 US) in Nigeria in 1985 to that in 1988?
Provide a succinct answer. 2.44. What is the ratio of the Earning from trade(constant 2005 US) of Singapore in 1985 to that in 1988?
Offer a terse response. 0.63. What is the ratio of the Earning from trade(constant 2005 US) in Dominican Republic in 1985 to that in 1989?
Ensure brevity in your answer.  0.6. What is the ratio of the Earning from trade(constant 2005 US) in Nigeria in 1985 to that in 1989?
Provide a short and direct response. 1.78. What is the ratio of the Earning from trade(constant 2005 US) in Singapore in 1985 to that in 1989?
Ensure brevity in your answer.  0.57. What is the ratio of the Earning from trade(constant 2005 US) in Dominican Republic in 1986 to that in 1987?
Ensure brevity in your answer.  0.85. What is the ratio of the Earning from trade(constant 2005 US) of Nigeria in 1986 to that in 1987?
Your response must be concise. 1.59. What is the ratio of the Earning from trade(constant 2005 US) of Singapore in 1986 to that in 1987?
Give a very brief answer. 0.88. What is the ratio of the Earning from trade(constant 2005 US) of Dominican Republic in 1986 to that in 1988?
Make the answer very short. 0.83. What is the ratio of the Earning from trade(constant 2005 US) of Nigeria in 1986 to that in 1988?
Your answer should be compact. 1.7. What is the ratio of the Earning from trade(constant 2005 US) of Singapore in 1986 to that in 1988?
Ensure brevity in your answer.  0.7. What is the ratio of the Earning from trade(constant 2005 US) of Dominican Republic in 1986 to that in 1989?
Provide a succinct answer. 0.72. What is the ratio of the Earning from trade(constant 2005 US) in Nigeria in 1986 to that in 1989?
Keep it short and to the point. 1.25. What is the ratio of the Earning from trade(constant 2005 US) in Singapore in 1986 to that in 1989?
Offer a terse response. 0.64. What is the ratio of the Earning from trade(constant 2005 US) in Nigeria in 1987 to that in 1988?
Your answer should be compact. 1.07. What is the ratio of the Earning from trade(constant 2005 US) in Singapore in 1987 to that in 1988?
Your answer should be compact. 0.79. What is the ratio of the Earning from trade(constant 2005 US) of Dominican Republic in 1987 to that in 1989?
Provide a short and direct response. 0.85. What is the ratio of the Earning from trade(constant 2005 US) in Nigeria in 1987 to that in 1989?
Offer a very short reply. 0.78. What is the ratio of the Earning from trade(constant 2005 US) of Singapore in 1987 to that in 1989?
Your answer should be compact. 0.72. What is the ratio of the Earning from trade(constant 2005 US) of Dominican Republic in 1988 to that in 1989?
Make the answer very short. 0.86. What is the ratio of the Earning from trade(constant 2005 US) in Nigeria in 1988 to that in 1989?
Give a very brief answer. 0.73. What is the ratio of the Earning from trade(constant 2005 US) of Singapore in 1988 to that in 1989?
Keep it short and to the point. 0.91. What is the difference between the highest and the second highest Earning from trade(constant 2005 US) of Dominican Republic?
Make the answer very short. 7.79e+08. What is the difference between the highest and the second highest Earning from trade(constant 2005 US) of Nigeria?
Your answer should be very brief. 7.68e+09. What is the difference between the highest and the second highest Earning from trade(constant 2005 US) in Singapore?
Your answer should be very brief. 4.48e+09. What is the difference between the highest and the lowest Earning from trade(constant 2005 US) of Dominican Republic?
Offer a very short reply. 2.43e+09. What is the difference between the highest and the lowest Earning from trade(constant 2005 US) of Nigeria?
Provide a succinct answer. 1.75e+1. What is the difference between the highest and the lowest Earning from trade(constant 2005 US) in Singapore?
Make the answer very short. 2.43e+1. 